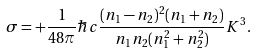Convert formula to latex. <formula><loc_0><loc_0><loc_500><loc_500>\sigma = + { \frac { 1 } { 4 8 \pi } } \hbar { c } { \frac { ( n _ { 1 } - n _ { 2 } ) ^ { 2 } ( n _ { 1 } + n _ { 2 } ) } { n _ { 1 } n _ { 2 } ( n _ { 1 } ^ { 2 } + n _ { 2 } ^ { 2 } ) } } K ^ { 3 } .</formula> 